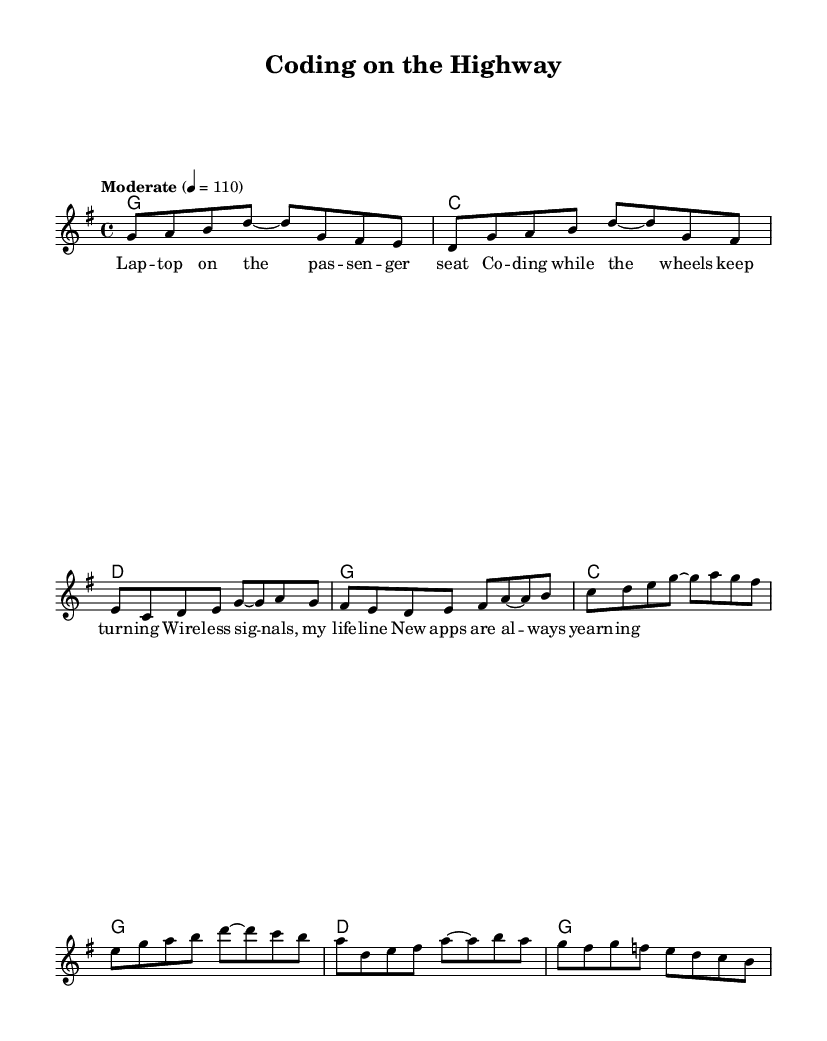What is the key signature of this music? The key signature is G major, which has one sharp (F#). This can be determined by looking at the key signature indicated at the beginning of the sheet music.
Answer: G major What is the time signature of this music? The time signature is 4/4, which means there are four beats in each measure and the quarter note receives one beat. This is shown at the beginning of the sheet music following the key signature.
Answer: 4/4 What is the tempo marking of this song? The tempo marking is "Moderate" with a tempo of 110 beats per minute. This is indicated at the beginning of the piece right after the time signature.
Answer: Moderate 110 How many measures are in the verse section? The verse section contains 4 measures, which can be identified by counting the groups of notes and bar lines in the melody section designated for the verse specifically.
Answer: 4 What is the first note of the chorus? The first note of the chorus is C. This can be found at the beginning of the chorus melody after the transition from the verse.
Answer: C What chords are used in the verse? The chords used in the verse are G, C, and D. This can be determined by looking at the chord changes indicated above the melody in the chord mode section for the verses.
Answer: G, C, D How does the structure of this song reflect its Country Rock genre? The structure reflects the Country Rock genre through its storytelling lyrical content about life on the road, combined with a combination of guitar-based music and a moderate tempo, typical for this genre. This understanding comes from examining both the lyrics and the feel of the melody.
Answer: Storytelling and guitar-based 